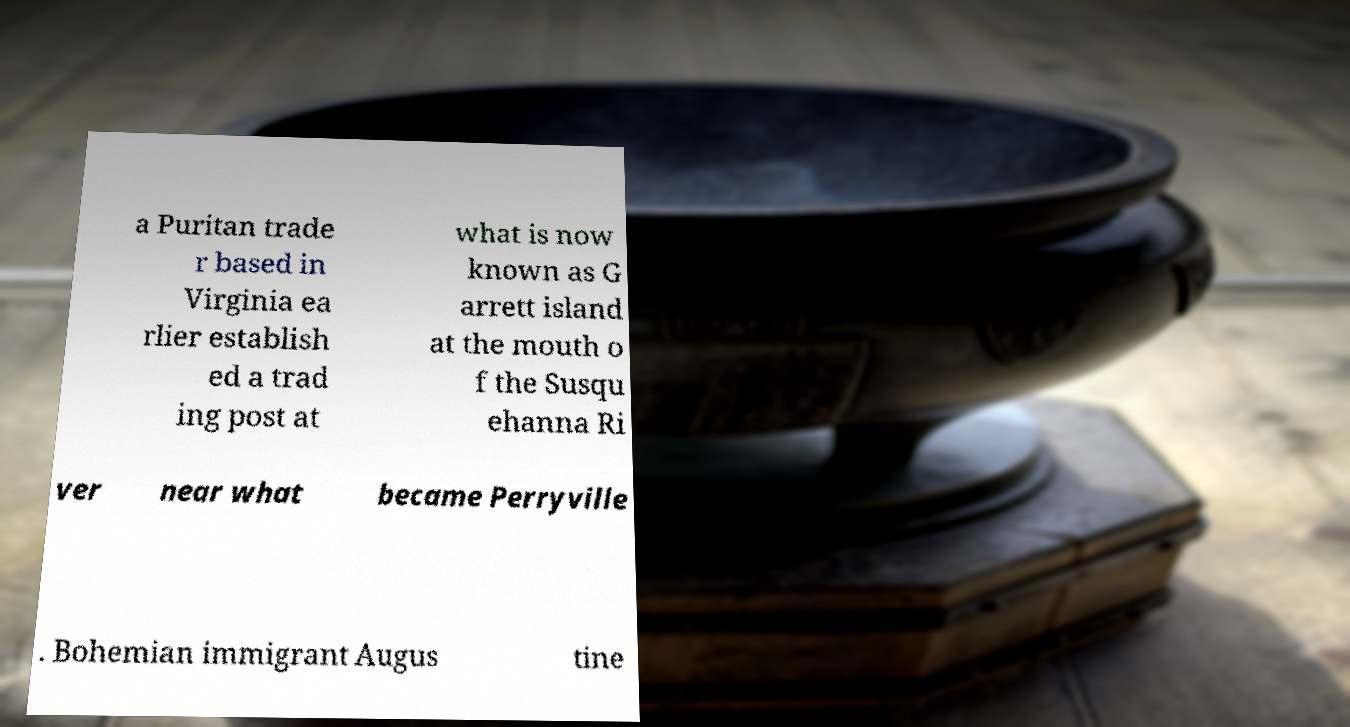For documentation purposes, I need the text within this image transcribed. Could you provide that? a Puritan trade r based in Virginia ea rlier establish ed a trad ing post at what is now known as G arrett island at the mouth o f the Susqu ehanna Ri ver near what became Perryville . Bohemian immigrant Augus tine 